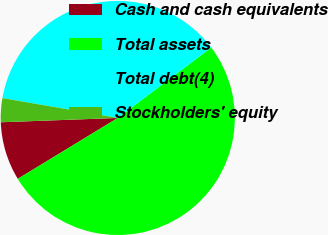Convert chart to OTSL. <chart><loc_0><loc_0><loc_500><loc_500><pie_chart><fcel>Cash and cash equivalents<fcel>Total assets<fcel>Total debt(4)<fcel>Stockholders' equity<nl><fcel>8.12%<fcel>51.57%<fcel>37.01%<fcel>3.3%<nl></chart> 